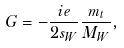Convert formula to latex. <formula><loc_0><loc_0><loc_500><loc_500>G = - { \frac { i e } { 2 s _ { W } } } { \frac { m _ { t } } { M _ { W } } } ,</formula> 